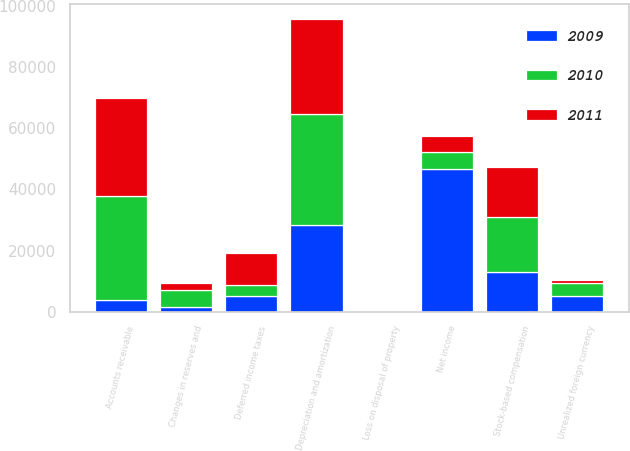Convert chart to OTSL. <chart><loc_0><loc_0><loc_500><loc_500><stacked_bar_chart><ecel><fcel>Net income<fcel>Depreciation and amortization<fcel>Unrealized foreign currency<fcel>Loss on disposal of property<fcel>Stock-based compensation<fcel>Deferred income taxes<fcel>Changes in reserves and<fcel>Accounts receivable<nl><fcel>2010<fcel>5379<fcel>36301<fcel>4027<fcel>36<fcel>18063<fcel>3620<fcel>5536<fcel>33923<nl><fcel>2011<fcel>5379<fcel>31321<fcel>1280<fcel>44<fcel>16227<fcel>10337<fcel>2322<fcel>32320<nl><fcel>2009<fcel>46785<fcel>28249<fcel>5222<fcel>37<fcel>12910<fcel>5212<fcel>1623<fcel>3792<nl></chart> 